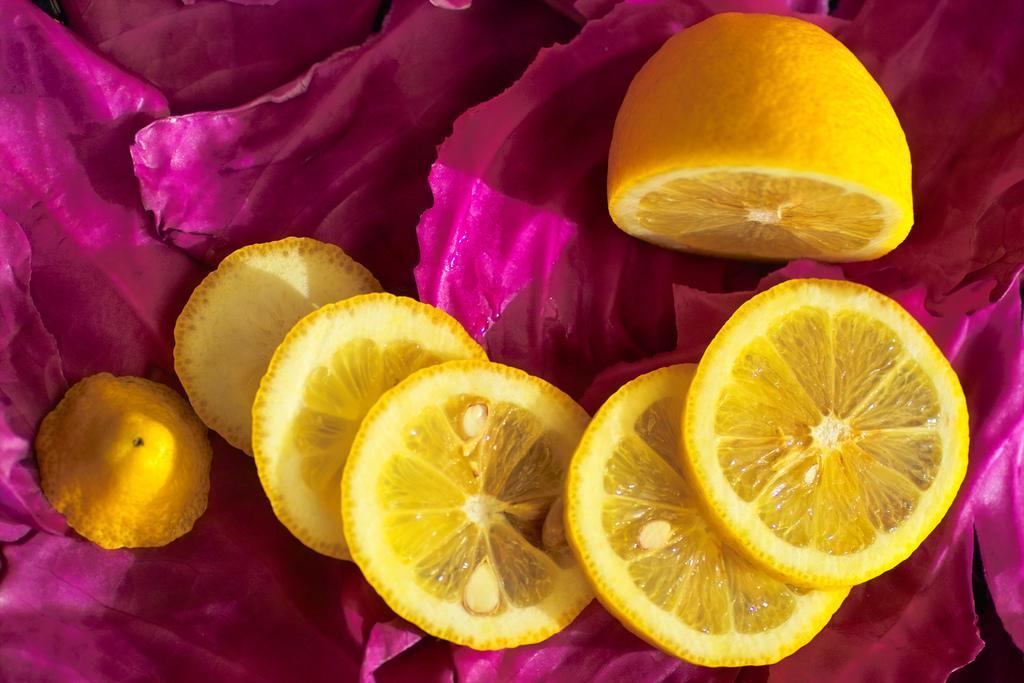How would you summarize this image in a sentence or two? In this image we can see the pieces of a lemon. Here we can see the dark pink leaves. 